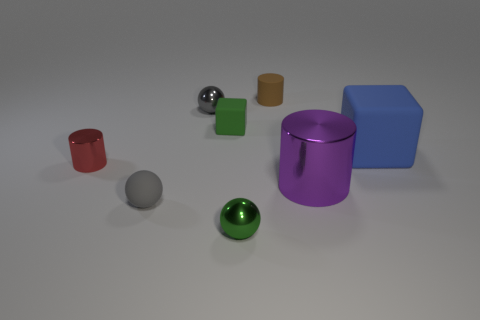What is the shape of the tiny thing that is the same color as the tiny block?
Ensure brevity in your answer.  Sphere. Is the color of the tiny ball that is behind the small gray matte sphere the same as the small rubber ball?
Offer a very short reply. Yes. Are there any other things of the same color as the matte sphere?
Offer a very short reply. Yes. There is a small object that is the same shape as the big blue matte thing; what material is it?
Keep it short and to the point. Rubber. Are there more tiny cylinders that are on the right side of the tiny gray metallic sphere than large blue metallic things?
Make the answer very short. Yes. Are any tiny purple blocks visible?
Ensure brevity in your answer.  No. How many other things are there of the same shape as the green metal thing?
Give a very brief answer. 2. Does the tiny thing in front of the gray matte sphere have the same color as the matte block that is on the left side of the big purple metal cylinder?
Keep it short and to the point. Yes. How big is the green thing behind the block right of the block on the left side of the brown cylinder?
Give a very brief answer. Small. The small metallic object that is left of the tiny green metallic sphere and right of the tiny red cylinder has what shape?
Your answer should be very brief. Sphere. 